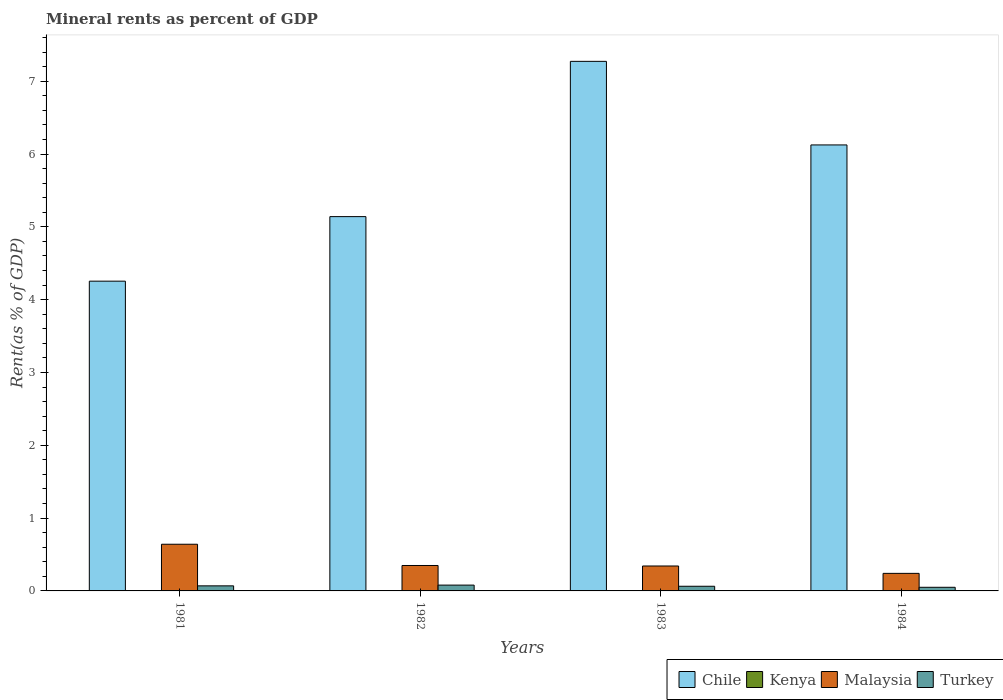How many groups of bars are there?
Your response must be concise. 4. Are the number of bars on each tick of the X-axis equal?
Your answer should be very brief. Yes. How many bars are there on the 1st tick from the left?
Make the answer very short. 4. What is the mineral rent in Chile in 1982?
Give a very brief answer. 5.14. Across all years, what is the maximum mineral rent in Malaysia?
Provide a short and direct response. 0.64. Across all years, what is the minimum mineral rent in Chile?
Ensure brevity in your answer.  4.25. In which year was the mineral rent in Kenya maximum?
Your answer should be compact. 1984. What is the total mineral rent in Chile in the graph?
Offer a terse response. 22.79. What is the difference between the mineral rent in Turkey in 1983 and that in 1984?
Offer a very short reply. 0.01. What is the difference between the mineral rent in Chile in 1981 and the mineral rent in Kenya in 1982?
Your response must be concise. 4.25. What is the average mineral rent in Kenya per year?
Your response must be concise. 0. In the year 1982, what is the difference between the mineral rent in Kenya and mineral rent in Malaysia?
Provide a succinct answer. -0.35. In how many years, is the mineral rent in Turkey greater than 2.6 %?
Give a very brief answer. 0. What is the ratio of the mineral rent in Malaysia in 1982 to that in 1983?
Offer a terse response. 1.02. Is the mineral rent in Chile in 1981 less than that in 1984?
Provide a succinct answer. Yes. What is the difference between the highest and the second highest mineral rent in Chile?
Keep it short and to the point. 1.15. What is the difference between the highest and the lowest mineral rent in Turkey?
Keep it short and to the point. 0.03. In how many years, is the mineral rent in Kenya greater than the average mineral rent in Kenya taken over all years?
Offer a terse response. 1. What does the 1st bar from the left in 1983 represents?
Your answer should be very brief. Chile. What does the 3rd bar from the right in 1983 represents?
Give a very brief answer. Kenya. Are all the bars in the graph horizontal?
Offer a terse response. No. How many years are there in the graph?
Make the answer very short. 4. What is the difference between two consecutive major ticks on the Y-axis?
Offer a very short reply. 1. Are the values on the major ticks of Y-axis written in scientific E-notation?
Your answer should be compact. No. Does the graph contain any zero values?
Provide a succinct answer. No. Does the graph contain grids?
Your answer should be compact. No. How many legend labels are there?
Give a very brief answer. 4. How are the legend labels stacked?
Offer a terse response. Horizontal. What is the title of the graph?
Your response must be concise. Mineral rents as percent of GDP. What is the label or title of the X-axis?
Offer a terse response. Years. What is the label or title of the Y-axis?
Provide a short and direct response. Rent(as % of GDP). What is the Rent(as % of GDP) in Chile in 1981?
Offer a very short reply. 4.25. What is the Rent(as % of GDP) of Kenya in 1981?
Give a very brief answer. 9.89683064769055e-5. What is the Rent(as % of GDP) in Malaysia in 1981?
Your answer should be compact. 0.64. What is the Rent(as % of GDP) in Turkey in 1981?
Provide a succinct answer. 0.07. What is the Rent(as % of GDP) of Chile in 1982?
Provide a succinct answer. 5.14. What is the Rent(as % of GDP) of Kenya in 1982?
Your answer should be very brief. 6.72101396452568e-5. What is the Rent(as % of GDP) of Malaysia in 1982?
Make the answer very short. 0.35. What is the Rent(as % of GDP) in Turkey in 1982?
Offer a terse response. 0.08. What is the Rent(as % of GDP) of Chile in 1983?
Give a very brief answer. 7.27. What is the Rent(as % of GDP) in Kenya in 1983?
Make the answer very short. 0. What is the Rent(as % of GDP) in Malaysia in 1983?
Give a very brief answer. 0.34. What is the Rent(as % of GDP) of Turkey in 1983?
Give a very brief answer. 0.06. What is the Rent(as % of GDP) in Chile in 1984?
Give a very brief answer. 6.12. What is the Rent(as % of GDP) in Kenya in 1984?
Make the answer very short. 0. What is the Rent(as % of GDP) of Malaysia in 1984?
Provide a short and direct response. 0.24. What is the Rent(as % of GDP) in Turkey in 1984?
Provide a short and direct response. 0.05. Across all years, what is the maximum Rent(as % of GDP) in Chile?
Offer a terse response. 7.27. Across all years, what is the maximum Rent(as % of GDP) of Kenya?
Give a very brief answer. 0. Across all years, what is the maximum Rent(as % of GDP) in Malaysia?
Your answer should be compact. 0.64. Across all years, what is the maximum Rent(as % of GDP) of Turkey?
Your answer should be very brief. 0.08. Across all years, what is the minimum Rent(as % of GDP) in Chile?
Your answer should be very brief. 4.25. Across all years, what is the minimum Rent(as % of GDP) in Kenya?
Your answer should be very brief. 6.72101396452568e-5. Across all years, what is the minimum Rent(as % of GDP) in Malaysia?
Your answer should be very brief. 0.24. Across all years, what is the minimum Rent(as % of GDP) of Turkey?
Offer a very short reply. 0.05. What is the total Rent(as % of GDP) of Chile in the graph?
Offer a terse response. 22.79. What is the total Rent(as % of GDP) of Kenya in the graph?
Keep it short and to the point. 0. What is the total Rent(as % of GDP) of Malaysia in the graph?
Provide a succinct answer. 1.57. What is the total Rent(as % of GDP) of Turkey in the graph?
Give a very brief answer. 0.26. What is the difference between the Rent(as % of GDP) in Chile in 1981 and that in 1982?
Your answer should be very brief. -0.89. What is the difference between the Rent(as % of GDP) of Kenya in 1981 and that in 1982?
Provide a succinct answer. 0. What is the difference between the Rent(as % of GDP) in Malaysia in 1981 and that in 1982?
Make the answer very short. 0.29. What is the difference between the Rent(as % of GDP) in Turkey in 1981 and that in 1982?
Provide a succinct answer. -0.01. What is the difference between the Rent(as % of GDP) of Chile in 1981 and that in 1983?
Provide a succinct answer. -3.02. What is the difference between the Rent(as % of GDP) in Kenya in 1981 and that in 1983?
Make the answer very short. -0. What is the difference between the Rent(as % of GDP) of Malaysia in 1981 and that in 1983?
Ensure brevity in your answer.  0.3. What is the difference between the Rent(as % of GDP) in Turkey in 1981 and that in 1983?
Give a very brief answer. 0.01. What is the difference between the Rent(as % of GDP) of Chile in 1981 and that in 1984?
Offer a terse response. -1.87. What is the difference between the Rent(as % of GDP) of Kenya in 1981 and that in 1984?
Your response must be concise. -0. What is the difference between the Rent(as % of GDP) of Malaysia in 1981 and that in 1984?
Provide a succinct answer. 0.4. What is the difference between the Rent(as % of GDP) in Turkey in 1981 and that in 1984?
Ensure brevity in your answer.  0.02. What is the difference between the Rent(as % of GDP) of Chile in 1982 and that in 1983?
Your answer should be compact. -2.13. What is the difference between the Rent(as % of GDP) of Kenya in 1982 and that in 1983?
Offer a very short reply. -0. What is the difference between the Rent(as % of GDP) in Malaysia in 1982 and that in 1983?
Ensure brevity in your answer.  0.01. What is the difference between the Rent(as % of GDP) of Turkey in 1982 and that in 1983?
Provide a succinct answer. 0.02. What is the difference between the Rent(as % of GDP) of Chile in 1982 and that in 1984?
Your response must be concise. -0.98. What is the difference between the Rent(as % of GDP) in Kenya in 1982 and that in 1984?
Your response must be concise. -0. What is the difference between the Rent(as % of GDP) in Malaysia in 1982 and that in 1984?
Ensure brevity in your answer.  0.11. What is the difference between the Rent(as % of GDP) of Turkey in 1982 and that in 1984?
Give a very brief answer. 0.03. What is the difference between the Rent(as % of GDP) in Chile in 1983 and that in 1984?
Offer a very short reply. 1.15. What is the difference between the Rent(as % of GDP) of Kenya in 1983 and that in 1984?
Make the answer very short. -0. What is the difference between the Rent(as % of GDP) in Malaysia in 1983 and that in 1984?
Ensure brevity in your answer.  0.1. What is the difference between the Rent(as % of GDP) in Turkey in 1983 and that in 1984?
Offer a very short reply. 0.01. What is the difference between the Rent(as % of GDP) of Chile in 1981 and the Rent(as % of GDP) of Kenya in 1982?
Offer a very short reply. 4.25. What is the difference between the Rent(as % of GDP) of Chile in 1981 and the Rent(as % of GDP) of Malaysia in 1982?
Your response must be concise. 3.9. What is the difference between the Rent(as % of GDP) of Chile in 1981 and the Rent(as % of GDP) of Turkey in 1982?
Give a very brief answer. 4.17. What is the difference between the Rent(as % of GDP) of Kenya in 1981 and the Rent(as % of GDP) of Malaysia in 1982?
Make the answer very short. -0.35. What is the difference between the Rent(as % of GDP) of Kenya in 1981 and the Rent(as % of GDP) of Turkey in 1982?
Your answer should be very brief. -0.08. What is the difference between the Rent(as % of GDP) of Malaysia in 1981 and the Rent(as % of GDP) of Turkey in 1982?
Your answer should be compact. 0.56. What is the difference between the Rent(as % of GDP) in Chile in 1981 and the Rent(as % of GDP) in Kenya in 1983?
Offer a terse response. 4.25. What is the difference between the Rent(as % of GDP) of Chile in 1981 and the Rent(as % of GDP) of Malaysia in 1983?
Offer a terse response. 3.91. What is the difference between the Rent(as % of GDP) in Chile in 1981 and the Rent(as % of GDP) in Turkey in 1983?
Your response must be concise. 4.19. What is the difference between the Rent(as % of GDP) in Kenya in 1981 and the Rent(as % of GDP) in Malaysia in 1983?
Offer a terse response. -0.34. What is the difference between the Rent(as % of GDP) of Kenya in 1981 and the Rent(as % of GDP) of Turkey in 1983?
Your response must be concise. -0.06. What is the difference between the Rent(as % of GDP) in Malaysia in 1981 and the Rent(as % of GDP) in Turkey in 1983?
Give a very brief answer. 0.58. What is the difference between the Rent(as % of GDP) of Chile in 1981 and the Rent(as % of GDP) of Kenya in 1984?
Keep it short and to the point. 4.25. What is the difference between the Rent(as % of GDP) of Chile in 1981 and the Rent(as % of GDP) of Malaysia in 1984?
Offer a terse response. 4.01. What is the difference between the Rent(as % of GDP) in Chile in 1981 and the Rent(as % of GDP) in Turkey in 1984?
Ensure brevity in your answer.  4.2. What is the difference between the Rent(as % of GDP) in Kenya in 1981 and the Rent(as % of GDP) in Malaysia in 1984?
Give a very brief answer. -0.24. What is the difference between the Rent(as % of GDP) of Kenya in 1981 and the Rent(as % of GDP) of Turkey in 1984?
Offer a terse response. -0.05. What is the difference between the Rent(as % of GDP) in Malaysia in 1981 and the Rent(as % of GDP) in Turkey in 1984?
Your response must be concise. 0.59. What is the difference between the Rent(as % of GDP) in Chile in 1982 and the Rent(as % of GDP) in Kenya in 1983?
Give a very brief answer. 5.14. What is the difference between the Rent(as % of GDP) of Chile in 1982 and the Rent(as % of GDP) of Malaysia in 1983?
Give a very brief answer. 4.8. What is the difference between the Rent(as % of GDP) in Chile in 1982 and the Rent(as % of GDP) in Turkey in 1983?
Your answer should be compact. 5.08. What is the difference between the Rent(as % of GDP) in Kenya in 1982 and the Rent(as % of GDP) in Malaysia in 1983?
Provide a short and direct response. -0.34. What is the difference between the Rent(as % of GDP) in Kenya in 1982 and the Rent(as % of GDP) in Turkey in 1983?
Provide a succinct answer. -0.06. What is the difference between the Rent(as % of GDP) in Malaysia in 1982 and the Rent(as % of GDP) in Turkey in 1983?
Your response must be concise. 0.29. What is the difference between the Rent(as % of GDP) of Chile in 1982 and the Rent(as % of GDP) of Kenya in 1984?
Make the answer very short. 5.14. What is the difference between the Rent(as % of GDP) of Chile in 1982 and the Rent(as % of GDP) of Malaysia in 1984?
Make the answer very short. 4.9. What is the difference between the Rent(as % of GDP) in Chile in 1982 and the Rent(as % of GDP) in Turkey in 1984?
Your answer should be compact. 5.09. What is the difference between the Rent(as % of GDP) of Kenya in 1982 and the Rent(as % of GDP) of Malaysia in 1984?
Offer a very short reply. -0.24. What is the difference between the Rent(as % of GDP) of Kenya in 1982 and the Rent(as % of GDP) of Turkey in 1984?
Keep it short and to the point. -0.05. What is the difference between the Rent(as % of GDP) in Malaysia in 1982 and the Rent(as % of GDP) in Turkey in 1984?
Your answer should be very brief. 0.3. What is the difference between the Rent(as % of GDP) of Chile in 1983 and the Rent(as % of GDP) of Kenya in 1984?
Provide a succinct answer. 7.27. What is the difference between the Rent(as % of GDP) in Chile in 1983 and the Rent(as % of GDP) in Malaysia in 1984?
Give a very brief answer. 7.03. What is the difference between the Rent(as % of GDP) in Chile in 1983 and the Rent(as % of GDP) in Turkey in 1984?
Your answer should be very brief. 7.22. What is the difference between the Rent(as % of GDP) in Kenya in 1983 and the Rent(as % of GDP) in Malaysia in 1984?
Offer a terse response. -0.24. What is the difference between the Rent(as % of GDP) of Kenya in 1983 and the Rent(as % of GDP) of Turkey in 1984?
Your answer should be compact. -0.05. What is the difference between the Rent(as % of GDP) in Malaysia in 1983 and the Rent(as % of GDP) in Turkey in 1984?
Make the answer very short. 0.29. What is the average Rent(as % of GDP) in Chile per year?
Offer a terse response. 5.7. What is the average Rent(as % of GDP) of Malaysia per year?
Your response must be concise. 0.39. What is the average Rent(as % of GDP) in Turkey per year?
Your answer should be compact. 0.07. In the year 1981, what is the difference between the Rent(as % of GDP) in Chile and Rent(as % of GDP) in Kenya?
Your answer should be compact. 4.25. In the year 1981, what is the difference between the Rent(as % of GDP) of Chile and Rent(as % of GDP) of Malaysia?
Your answer should be very brief. 3.61. In the year 1981, what is the difference between the Rent(as % of GDP) of Chile and Rent(as % of GDP) of Turkey?
Offer a very short reply. 4.18. In the year 1981, what is the difference between the Rent(as % of GDP) in Kenya and Rent(as % of GDP) in Malaysia?
Provide a succinct answer. -0.64. In the year 1981, what is the difference between the Rent(as % of GDP) of Kenya and Rent(as % of GDP) of Turkey?
Keep it short and to the point. -0.07. In the year 1982, what is the difference between the Rent(as % of GDP) of Chile and Rent(as % of GDP) of Kenya?
Offer a terse response. 5.14. In the year 1982, what is the difference between the Rent(as % of GDP) of Chile and Rent(as % of GDP) of Malaysia?
Ensure brevity in your answer.  4.79. In the year 1982, what is the difference between the Rent(as % of GDP) of Chile and Rent(as % of GDP) of Turkey?
Provide a short and direct response. 5.06. In the year 1982, what is the difference between the Rent(as % of GDP) in Kenya and Rent(as % of GDP) in Malaysia?
Keep it short and to the point. -0.35. In the year 1982, what is the difference between the Rent(as % of GDP) of Kenya and Rent(as % of GDP) of Turkey?
Make the answer very short. -0.08. In the year 1982, what is the difference between the Rent(as % of GDP) in Malaysia and Rent(as % of GDP) in Turkey?
Your answer should be very brief. 0.27. In the year 1983, what is the difference between the Rent(as % of GDP) in Chile and Rent(as % of GDP) in Kenya?
Make the answer very short. 7.27. In the year 1983, what is the difference between the Rent(as % of GDP) of Chile and Rent(as % of GDP) of Malaysia?
Your answer should be compact. 6.93. In the year 1983, what is the difference between the Rent(as % of GDP) of Chile and Rent(as % of GDP) of Turkey?
Keep it short and to the point. 7.21. In the year 1983, what is the difference between the Rent(as % of GDP) of Kenya and Rent(as % of GDP) of Malaysia?
Keep it short and to the point. -0.34. In the year 1983, what is the difference between the Rent(as % of GDP) in Kenya and Rent(as % of GDP) in Turkey?
Make the answer very short. -0.06. In the year 1983, what is the difference between the Rent(as % of GDP) in Malaysia and Rent(as % of GDP) in Turkey?
Your answer should be very brief. 0.28. In the year 1984, what is the difference between the Rent(as % of GDP) in Chile and Rent(as % of GDP) in Kenya?
Offer a very short reply. 6.12. In the year 1984, what is the difference between the Rent(as % of GDP) of Chile and Rent(as % of GDP) of Malaysia?
Ensure brevity in your answer.  5.88. In the year 1984, what is the difference between the Rent(as % of GDP) in Chile and Rent(as % of GDP) in Turkey?
Your response must be concise. 6.08. In the year 1984, what is the difference between the Rent(as % of GDP) in Kenya and Rent(as % of GDP) in Malaysia?
Give a very brief answer. -0.24. In the year 1984, what is the difference between the Rent(as % of GDP) of Kenya and Rent(as % of GDP) of Turkey?
Your answer should be very brief. -0.05. In the year 1984, what is the difference between the Rent(as % of GDP) in Malaysia and Rent(as % of GDP) in Turkey?
Make the answer very short. 0.19. What is the ratio of the Rent(as % of GDP) in Chile in 1981 to that in 1982?
Offer a very short reply. 0.83. What is the ratio of the Rent(as % of GDP) of Kenya in 1981 to that in 1982?
Offer a very short reply. 1.47. What is the ratio of the Rent(as % of GDP) of Malaysia in 1981 to that in 1982?
Ensure brevity in your answer.  1.84. What is the ratio of the Rent(as % of GDP) of Turkey in 1981 to that in 1982?
Offer a very short reply. 0.87. What is the ratio of the Rent(as % of GDP) of Chile in 1981 to that in 1983?
Your response must be concise. 0.58. What is the ratio of the Rent(as % of GDP) in Kenya in 1981 to that in 1983?
Your answer should be very brief. 0.33. What is the ratio of the Rent(as % of GDP) of Malaysia in 1981 to that in 1983?
Keep it short and to the point. 1.87. What is the ratio of the Rent(as % of GDP) of Turkey in 1981 to that in 1983?
Give a very brief answer. 1.08. What is the ratio of the Rent(as % of GDP) of Chile in 1981 to that in 1984?
Give a very brief answer. 0.69. What is the ratio of the Rent(as % of GDP) in Kenya in 1981 to that in 1984?
Your answer should be very brief. 0.08. What is the ratio of the Rent(as % of GDP) of Malaysia in 1981 to that in 1984?
Offer a terse response. 2.66. What is the ratio of the Rent(as % of GDP) of Turkey in 1981 to that in 1984?
Make the answer very short. 1.4. What is the ratio of the Rent(as % of GDP) in Chile in 1982 to that in 1983?
Provide a succinct answer. 0.71. What is the ratio of the Rent(as % of GDP) in Kenya in 1982 to that in 1983?
Your answer should be very brief. 0.22. What is the ratio of the Rent(as % of GDP) in Turkey in 1982 to that in 1983?
Provide a succinct answer. 1.25. What is the ratio of the Rent(as % of GDP) in Chile in 1982 to that in 1984?
Provide a succinct answer. 0.84. What is the ratio of the Rent(as % of GDP) of Kenya in 1982 to that in 1984?
Your answer should be very brief. 0.05. What is the ratio of the Rent(as % of GDP) in Malaysia in 1982 to that in 1984?
Keep it short and to the point. 1.45. What is the ratio of the Rent(as % of GDP) of Turkey in 1982 to that in 1984?
Your response must be concise. 1.61. What is the ratio of the Rent(as % of GDP) in Chile in 1983 to that in 1984?
Offer a terse response. 1.19. What is the ratio of the Rent(as % of GDP) of Kenya in 1983 to that in 1984?
Offer a very short reply. 0.23. What is the ratio of the Rent(as % of GDP) in Malaysia in 1983 to that in 1984?
Give a very brief answer. 1.42. What is the ratio of the Rent(as % of GDP) in Turkey in 1983 to that in 1984?
Your response must be concise. 1.29. What is the difference between the highest and the second highest Rent(as % of GDP) in Chile?
Keep it short and to the point. 1.15. What is the difference between the highest and the second highest Rent(as % of GDP) of Malaysia?
Offer a very short reply. 0.29. What is the difference between the highest and the second highest Rent(as % of GDP) in Turkey?
Your answer should be very brief. 0.01. What is the difference between the highest and the lowest Rent(as % of GDP) of Chile?
Provide a succinct answer. 3.02. What is the difference between the highest and the lowest Rent(as % of GDP) of Kenya?
Offer a very short reply. 0. What is the difference between the highest and the lowest Rent(as % of GDP) of Malaysia?
Offer a terse response. 0.4. What is the difference between the highest and the lowest Rent(as % of GDP) in Turkey?
Offer a terse response. 0.03. 